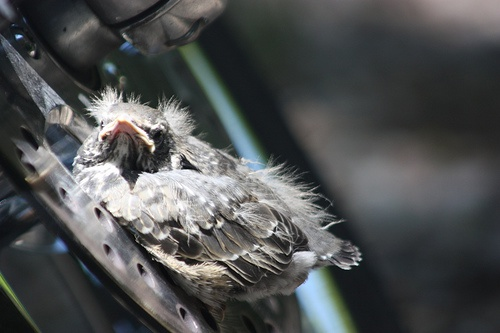Describe the objects in this image and their specific colors. I can see motorcycle in darkgray, black, gray, and lightblue tones and bird in darkgray, lightgray, gray, and black tones in this image. 